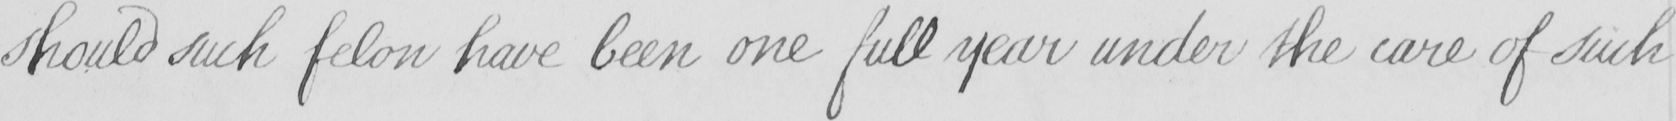What does this handwritten line say? should such felon have been one full year under the care of such 